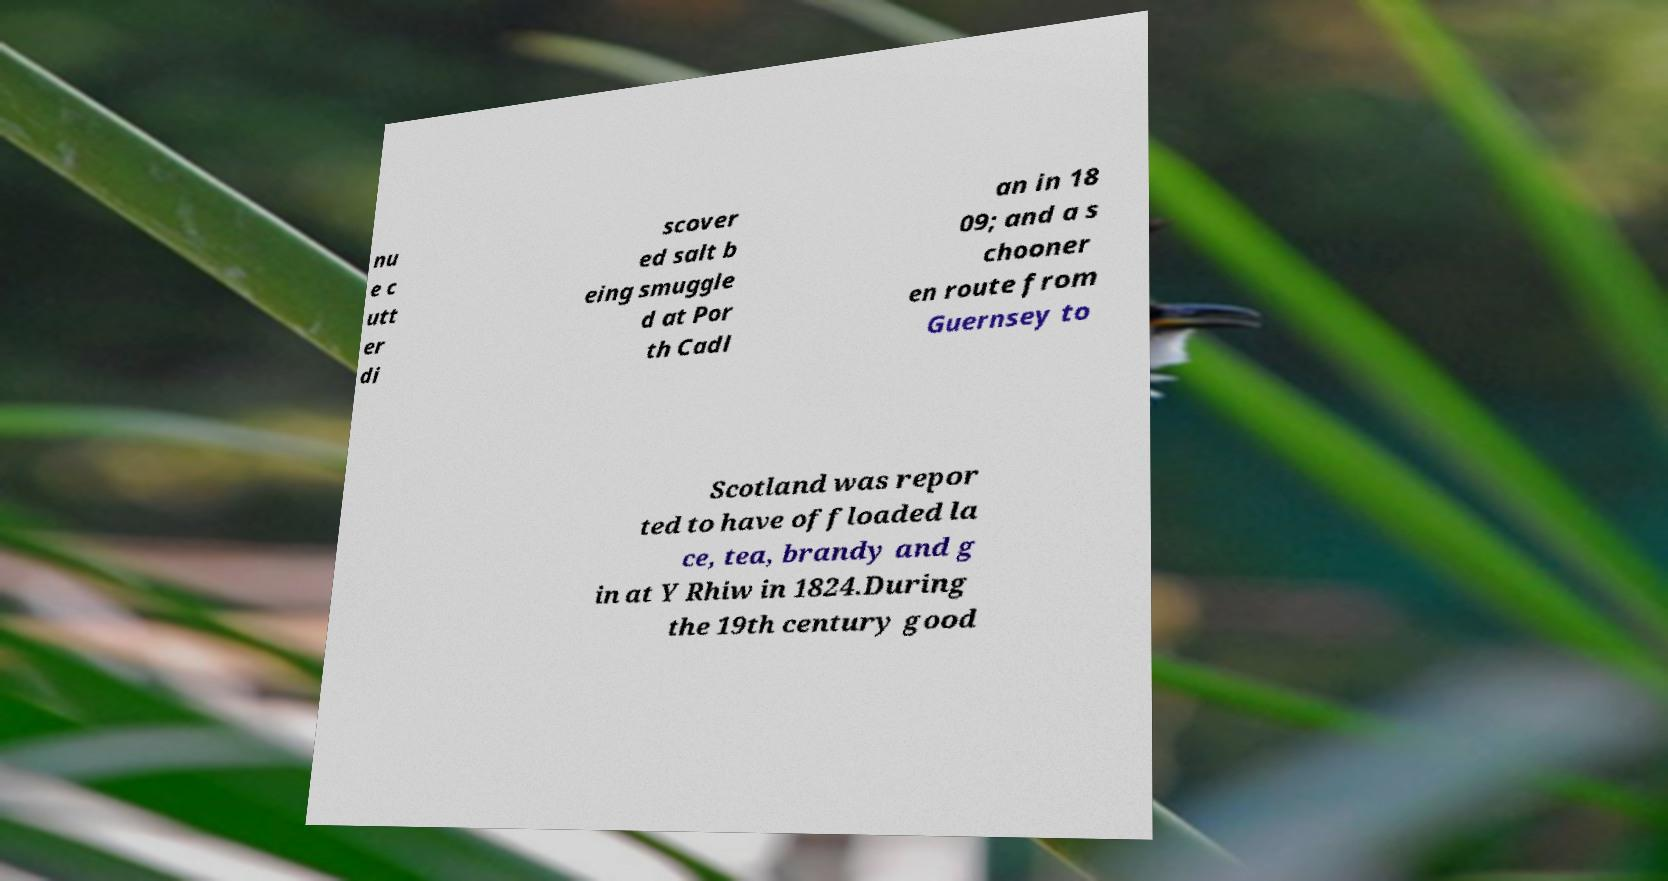Please read and relay the text visible in this image. What does it say? nu e c utt er di scover ed salt b eing smuggle d at Por th Cadl an in 18 09; and a s chooner en route from Guernsey to Scotland was repor ted to have offloaded la ce, tea, brandy and g in at Y Rhiw in 1824.During the 19th century good 